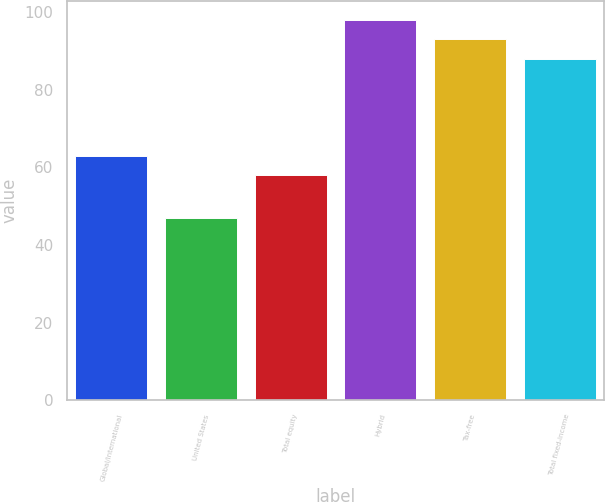Convert chart to OTSL. <chart><loc_0><loc_0><loc_500><loc_500><bar_chart><fcel>Global/international<fcel>United States<fcel>Total equity<fcel>Hybrid<fcel>Tax-free<fcel>Total fixed-income<nl><fcel>63<fcel>47<fcel>58<fcel>98<fcel>93<fcel>88<nl></chart> 